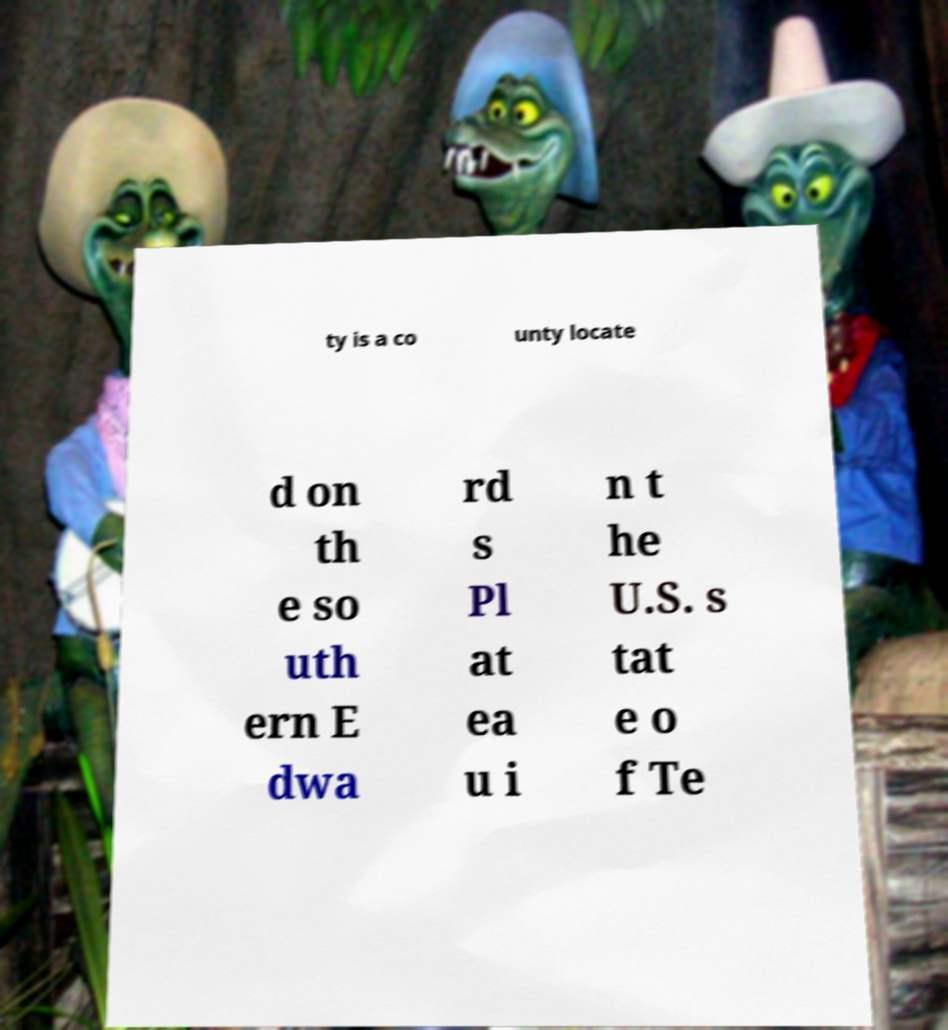Could you extract and type out the text from this image? ty is a co unty locate d on th e so uth ern E dwa rd s Pl at ea u i n t he U.S. s tat e o f Te 